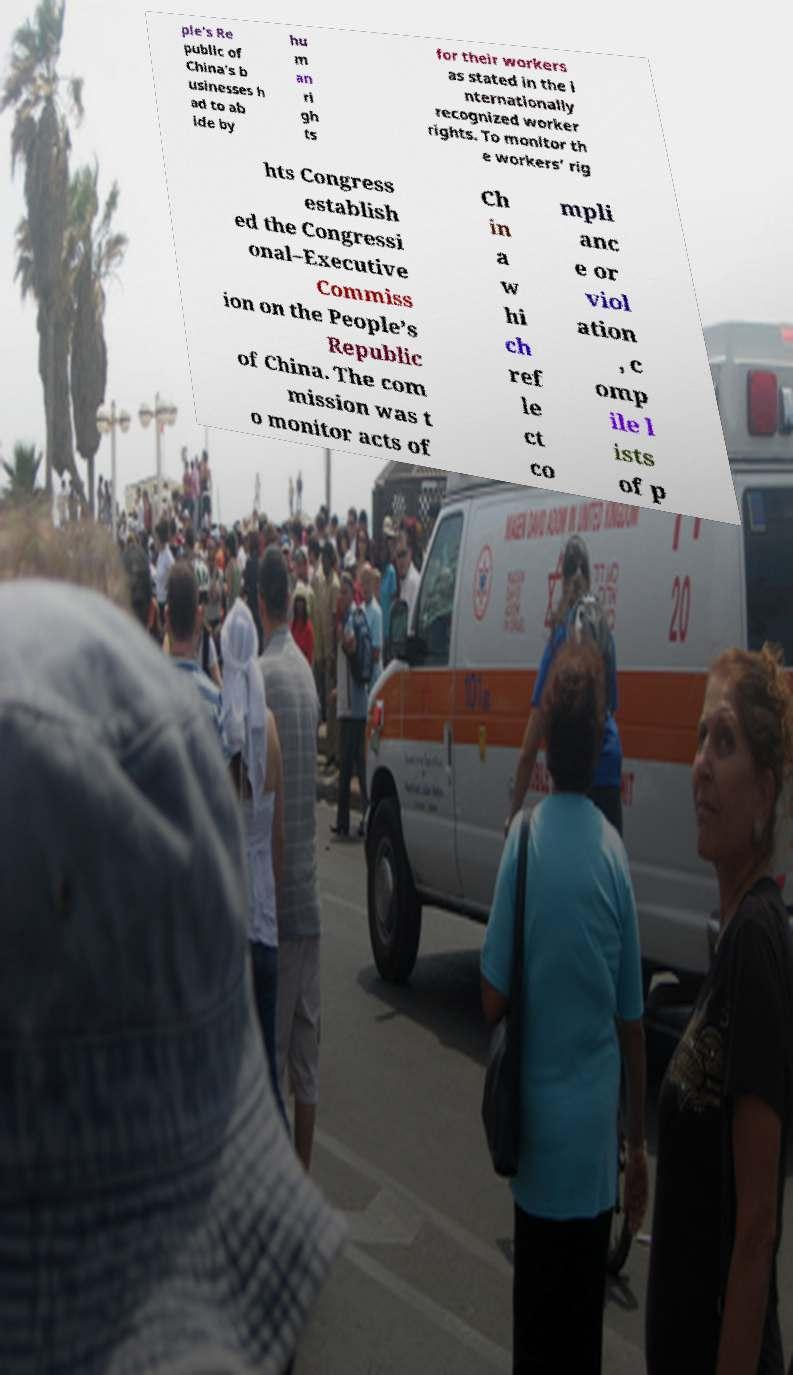Could you extract and type out the text from this image? ple’s Re public of China’s b usinesses h ad to ab ide by hu m an ri gh ts for their workers as stated in the i nternationally recognized worker rights. To monitor th e workers’ rig hts Congress establish ed the Congressi onal–Executive Commiss ion on the People’s Republic of China. The com mission was t o monitor acts of Ch in a w hi ch ref le ct co mpli anc e or viol ation , c omp ile l ists of p 